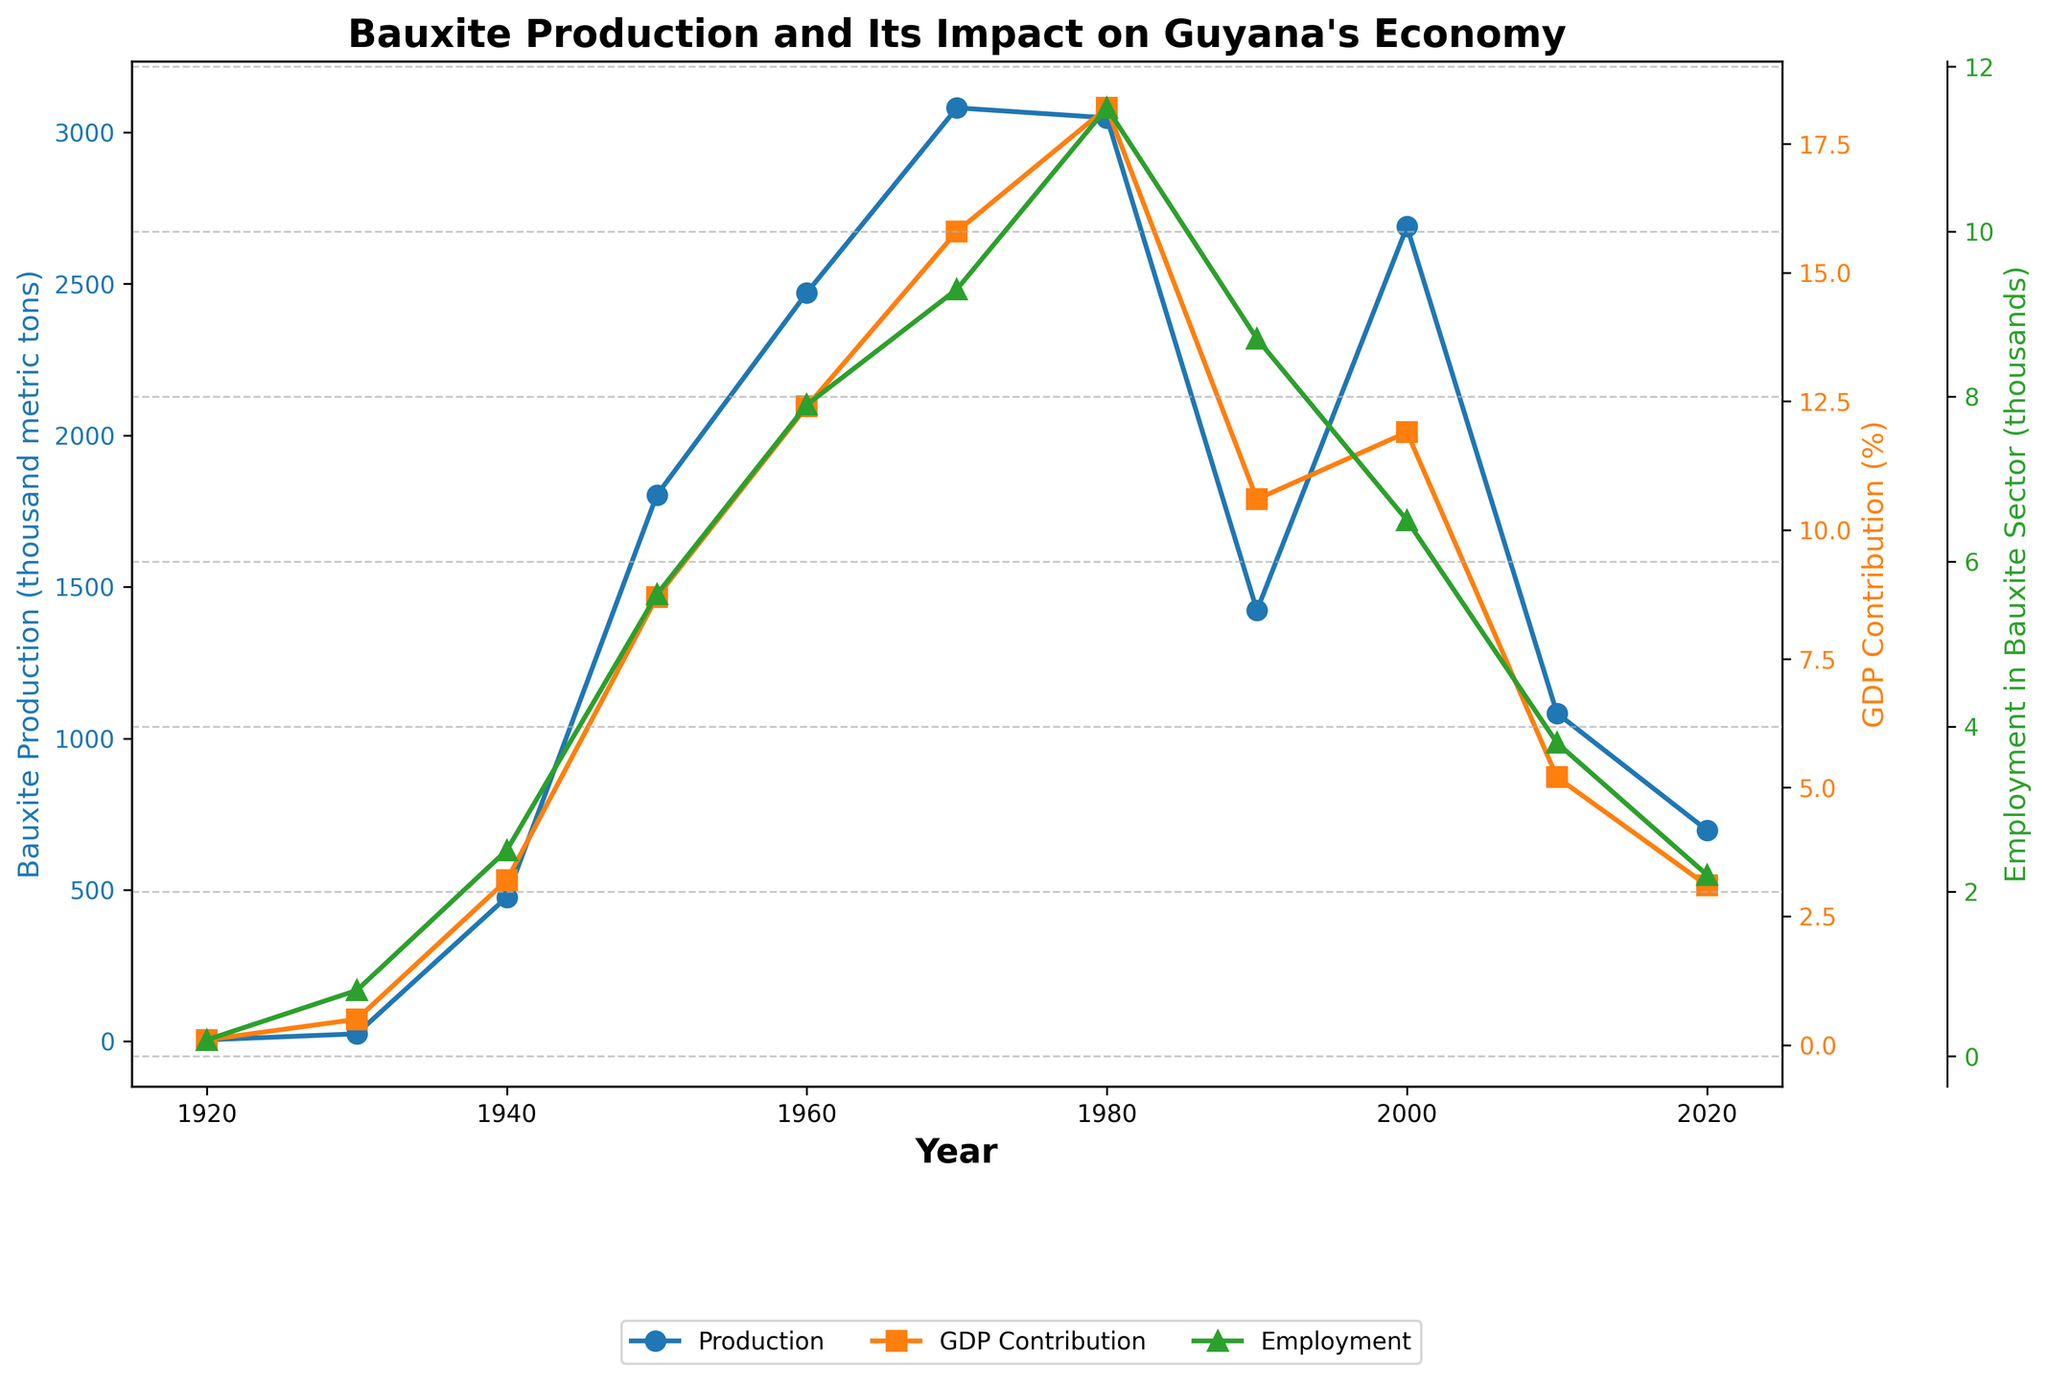What is the trend in bauxite production between 1920 and 1980? From 1920 to 1980, bauxite production in Guyana shows a steady increase. It starts at 5 thousand metric tons in 1920, reaching its peak in 1970 at 3081 thousand metric tons. By 1980, it slightly decreases to 3048 thousand metric tons.
Answer: Steady increase Compare the GDP Contribution (%) in 1980 and 2020. In 1980, the GDP Contribution (%) from bauxite production was 18.2%, while in 2020, it was 3.1%. The difference involves a substantial decrease over the years.
Answer: Decreased Which year shows the highest employment in the bauxite sector, and what is the corresponding bauxite production? The year 1980 shows the highest employment in the bauxite sector at 11.5 thousand workers. The corresponding bauxite production for that year is 3048 thousand metric tons.
Answer: 1980, 3048 thousand metric tons How does the GDP contribution in 1950 compare to that in 2010? In 1950, the GDP Contribution from bauxite was 8.7%, whereas in 2010, it was 5.2%. Therefore, the GDP contribution has decreased from 1950 to 2010.
Answer: Decreased Calculate the average bauxite production for the decade 1960-1970. Bauxite production in 1960 is 2471 thousand metric tons, and 1970 is 3081 thousand metric tons. The average is calculated as (2471 + 3081) / 2 = 2776 thousand metric tons.
Answer: 2776 thousand metric tons By how much did the bauxite production decrease from 2010 to 2020? Bauxite production in 2010 was 1083 thousand metric tons, and in 2020, it was 697 thousand metric tons. The decrease is calculated as 1083 - 697 = 386 thousand metric tons.
Answer: 386 thousand metric tons What color represents the employment in the bauxite sector in the chart, and which year had the second highest employment? Employment in the bauxite sector is represented by the color green. The second highest employment is observed in 1990, with 8.7 thousand workers.
Answer: Green, 1990 Which year had the highest percentage of GDP contribution from bauxite and what was the value? The highest percentage of GDP contribution from bauxite was in 1980, with a value of 18.2%.
Answer: 1980, 18.2% Describe the relationship between bauxite production and GDP contribution as observed from 1920 to 2020. As bauxite production increases, GDP contribution also increases initially until around 1980. After 1980, despite fluctuations in bauxite production, the GDP contribution generally decreases, indicating other economic factors may be influencing GDP more over time.
Answer: Direct correlation then divergence Compare the employment in the bauxite sector in 1950 and 2000. Employment in the bauxite sector was 5.6 thousand in 1950 and decreased to 6.5 thousand in 2000. There is a slight increase when compared to 1950.
Answer: Increase 